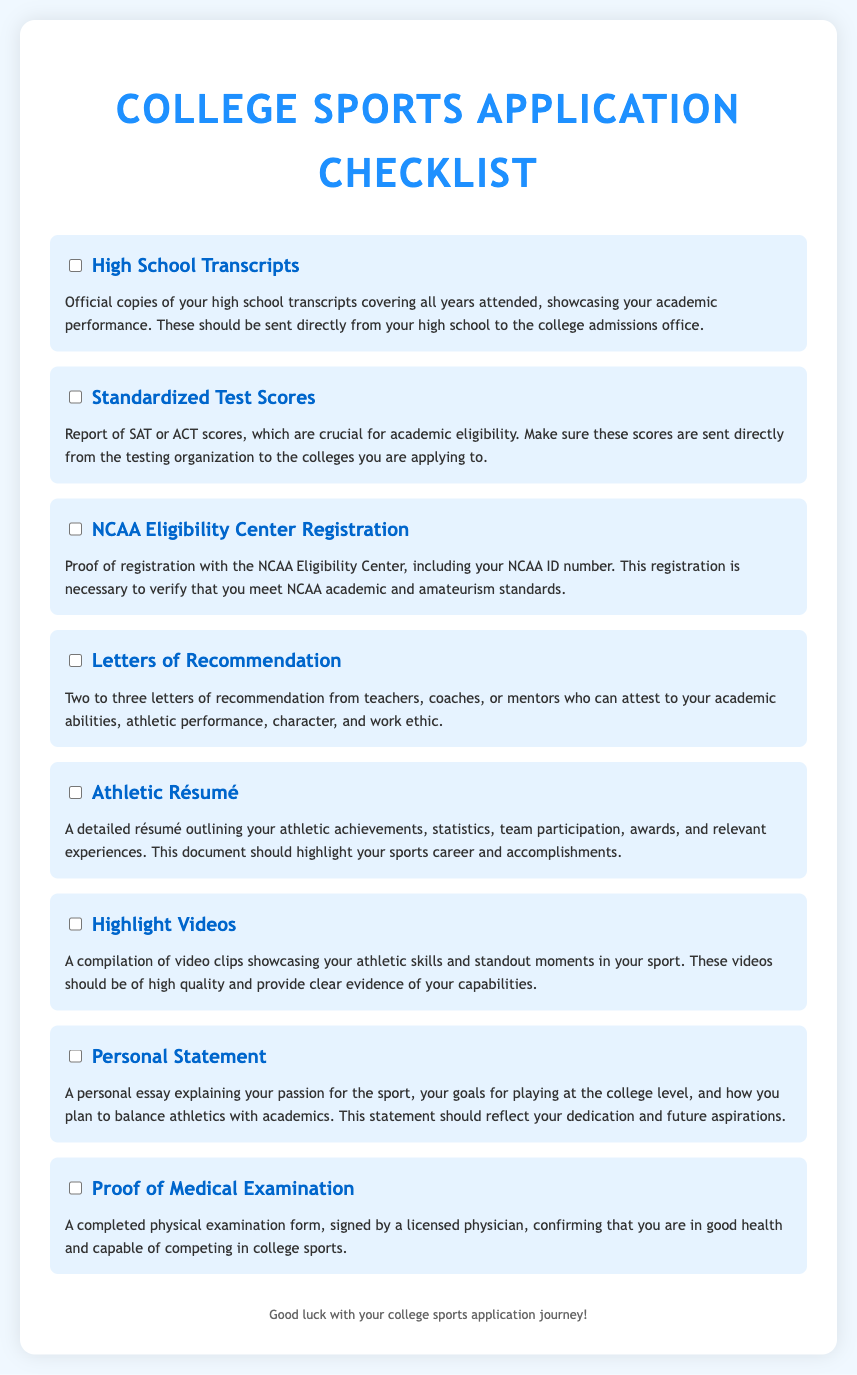what documentation is required for high school transcripts? The document specifies that official copies of your high school transcripts covering all years attended are needed.
Answer: Official copies of high school transcripts how many letters of recommendation are needed? The document states that two to three letters of recommendation are required.
Answer: Two to three what must be included with the NCAA Eligibility Center registration? The document mentions that proof of registration must include your NCAA ID number.
Answer: NCAA ID number what type of video submission is required? According to the document, a compilation of video clips showcasing athletic skills is required.
Answer: Compilation of video clips who can write the letters of recommendation? The document indicates that teachers, coaches, or mentors can write the letters of recommendation.
Answer: Teachers, coaches, or mentors what form must be completed for medical examination proof? The document specifies that a completed physical examination form must be signed by a licensed physician.
Answer: Completed physical examination form how should standardized test scores be submitted? The document notes that SAT or ACT scores must be sent directly from the testing organization.
Answer: Sent directly from the testing organization what should the personal statement reflect? The document states that the personal statement should reflect your dedication and future aspirations.
Answer: Dedication and future aspirations 